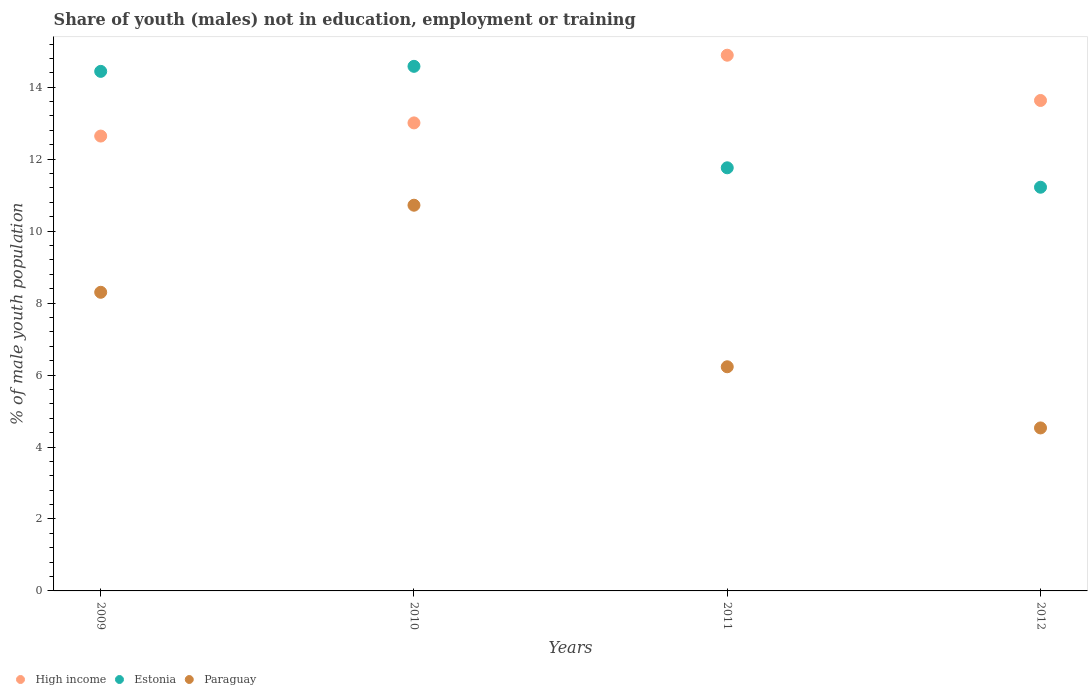How many different coloured dotlines are there?
Provide a succinct answer. 3. What is the percentage of unemployed males population in in High income in 2009?
Your answer should be compact. 12.64. Across all years, what is the maximum percentage of unemployed males population in in Estonia?
Make the answer very short. 14.58. Across all years, what is the minimum percentage of unemployed males population in in Estonia?
Offer a very short reply. 11.22. In which year was the percentage of unemployed males population in in Estonia maximum?
Provide a short and direct response. 2010. In which year was the percentage of unemployed males population in in Estonia minimum?
Provide a short and direct response. 2012. What is the total percentage of unemployed males population in in Paraguay in the graph?
Ensure brevity in your answer.  29.78. What is the difference between the percentage of unemployed males population in in Estonia in 2010 and that in 2011?
Ensure brevity in your answer.  2.82. What is the difference between the percentage of unemployed males population in in Paraguay in 2009 and the percentage of unemployed males population in in Estonia in 2012?
Provide a short and direct response. -2.92. What is the average percentage of unemployed males population in in Paraguay per year?
Provide a short and direct response. 7.45. In the year 2010, what is the difference between the percentage of unemployed males population in in High income and percentage of unemployed males population in in Estonia?
Your response must be concise. -1.57. In how many years, is the percentage of unemployed males population in in Estonia greater than 4 %?
Your response must be concise. 4. What is the ratio of the percentage of unemployed males population in in High income in 2009 to that in 2011?
Keep it short and to the point. 0.85. What is the difference between the highest and the second highest percentage of unemployed males population in in Paraguay?
Offer a very short reply. 2.42. What is the difference between the highest and the lowest percentage of unemployed males population in in High income?
Your answer should be very brief. 2.25. Is the percentage of unemployed males population in in Paraguay strictly greater than the percentage of unemployed males population in in Estonia over the years?
Provide a succinct answer. No. How many years are there in the graph?
Your answer should be very brief. 4. Are the values on the major ticks of Y-axis written in scientific E-notation?
Your answer should be compact. No. Where does the legend appear in the graph?
Keep it short and to the point. Bottom left. How many legend labels are there?
Provide a short and direct response. 3. How are the legend labels stacked?
Give a very brief answer. Horizontal. What is the title of the graph?
Your response must be concise. Share of youth (males) not in education, employment or training. What is the label or title of the X-axis?
Make the answer very short. Years. What is the label or title of the Y-axis?
Provide a short and direct response. % of male youth population. What is the % of male youth population in High income in 2009?
Keep it short and to the point. 12.64. What is the % of male youth population of Estonia in 2009?
Provide a short and direct response. 14.44. What is the % of male youth population in Paraguay in 2009?
Offer a very short reply. 8.3. What is the % of male youth population of High income in 2010?
Offer a very short reply. 13.01. What is the % of male youth population in Estonia in 2010?
Keep it short and to the point. 14.58. What is the % of male youth population of Paraguay in 2010?
Keep it short and to the point. 10.72. What is the % of male youth population of High income in 2011?
Make the answer very short. 14.89. What is the % of male youth population in Estonia in 2011?
Provide a short and direct response. 11.76. What is the % of male youth population in Paraguay in 2011?
Keep it short and to the point. 6.23. What is the % of male youth population of High income in 2012?
Ensure brevity in your answer.  13.63. What is the % of male youth population of Estonia in 2012?
Make the answer very short. 11.22. What is the % of male youth population of Paraguay in 2012?
Your response must be concise. 4.53. Across all years, what is the maximum % of male youth population of High income?
Your response must be concise. 14.89. Across all years, what is the maximum % of male youth population in Estonia?
Give a very brief answer. 14.58. Across all years, what is the maximum % of male youth population of Paraguay?
Provide a succinct answer. 10.72. Across all years, what is the minimum % of male youth population in High income?
Your answer should be compact. 12.64. Across all years, what is the minimum % of male youth population in Estonia?
Give a very brief answer. 11.22. Across all years, what is the minimum % of male youth population in Paraguay?
Your answer should be compact. 4.53. What is the total % of male youth population of High income in the graph?
Provide a succinct answer. 54.17. What is the total % of male youth population of Paraguay in the graph?
Offer a very short reply. 29.78. What is the difference between the % of male youth population in High income in 2009 and that in 2010?
Give a very brief answer. -0.37. What is the difference between the % of male youth population in Estonia in 2009 and that in 2010?
Give a very brief answer. -0.14. What is the difference between the % of male youth population in Paraguay in 2009 and that in 2010?
Provide a succinct answer. -2.42. What is the difference between the % of male youth population in High income in 2009 and that in 2011?
Give a very brief answer. -2.25. What is the difference between the % of male youth population of Estonia in 2009 and that in 2011?
Your answer should be very brief. 2.68. What is the difference between the % of male youth population of Paraguay in 2009 and that in 2011?
Provide a succinct answer. 2.07. What is the difference between the % of male youth population in High income in 2009 and that in 2012?
Give a very brief answer. -0.99. What is the difference between the % of male youth population in Estonia in 2009 and that in 2012?
Provide a short and direct response. 3.22. What is the difference between the % of male youth population in Paraguay in 2009 and that in 2012?
Provide a short and direct response. 3.77. What is the difference between the % of male youth population in High income in 2010 and that in 2011?
Provide a short and direct response. -1.88. What is the difference between the % of male youth population of Estonia in 2010 and that in 2011?
Make the answer very short. 2.82. What is the difference between the % of male youth population of Paraguay in 2010 and that in 2011?
Give a very brief answer. 4.49. What is the difference between the % of male youth population in High income in 2010 and that in 2012?
Ensure brevity in your answer.  -0.62. What is the difference between the % of male youth population of Estonia in 2010 and that in 2012?
Your response must be concise. 3.36. What is the difference between the % of male youth population of Paraguay in 2010 and that in 2012?
Offer a very short reply. 6.19. What is the difference between the % of male youth population of High income in 2011 and that in 2012?
Offer a terse response. 1.26. What is the difference between the % of male youth population in Estonia in 2011 and that in 2012?
Provide a short and direct response. 0.54. What is the difference between the % of male youth population in High income in 2009 and the % of male youth population in Estonia in 2010?
Your answer should be compact. -1.94. What is the difference between the % of male youth population in High income in 2009 and the % of male youth population in Paraguay in 2010?
Give a very brief answer. 1.92. What is the difference between the % of male youth population in Estonia in 2009 and the % of male youth population in Paraguay in 2010?
Ensure brevity in your answer.  3.72. What is the difference between the % of male youth population in High income in 2009 and the % of male youth population in Estonia in 2011?
Provide a succinct answer. 0.88. What is the difference between the % of male youth population of High income in 2009 and the % of male youth population of Paraguay in 2011?
Ensure brevity in your answer.  6.41. What is the difference between the % of male youth population in Estonia in 2009 and the % of male youth population in Paraguay in 2011?
Give a very brief answer. 8.21. What is the difference between the % of male youth population of High income in 2009 and the % of male youth population of Estonia in 2012?
Ensure brevity in your answer.  1.42. What is the difference between the % of male youth population in High income in 2009 and the % of male youth population in Paraguay in 2012?
Provide a short and direct response. 8.11. What is the difference between the % of male youth population of Estonia in 2009 and the % of male youth population of Paraguay in 2012?
Your response must be concise. 9.91. What is the difference between the % of male youth population in High income in 2010 and the % of male youth population in Estonia in 2011?
Offer a terse response. 1.25. What is the difference between the % of male youth population of High income in 2010 and the % of male youth population of Paraguay in 2011?
Make the answer very short. 6.78. What is the difference between the % of male youth population in Estonia in 2010 and the % of male youth population in Paraguay in 2011?
Offer a very short reply. 8.35. What is the difference between the % of male youth population of High income in 2010 and the % of male youth population of Estonia in 2012?
Your answer should be compact. 1.79. What is the difference between the % of male youth population in High income in 2010 and the % of male youth population in Paraguay in 2012?
Provide a succinct answer. 8.48. What is the difference between the % of male youth population of Estonia in 2010 and the % of male youth population of Paraguay in 2012?
Provide a succinct answer. 10.05. What is the difference between the % of male youth population in High income in 2011 and the % of male youth population in Estonia in 2012?
Keep it short and to the point. 3.67. What is the difference between the % of male youth population of High income in 2011 and the % of male youth population of Paraguay in 2012?
Your answer should be very brief. 10.36. What is the difference between the % of male youth population of Estonia in 2011 and the % of male youth population of Paraguay in 2012?
Provide a short and direct response. 7.23. What is the average % of male youth population of High income per year?
Make the answer very short. 13.54. What is the average % of male youth population in Paraguay per year?
Ensure brevity in your answer.  7.45. In the year 2009, what is the difference between the % of male youth population in High income and % of male youth population in Estonia?
Provide a succinct answer. -1.8. In the year 2009, what is the difference between the % of male youth population of High income and % of male youth population of Paraguay?
Offer a very short reply. 4.34. In the year 2009, what is the difference between the % of male youth population in Estonia and % of male youth population in Paraguay?
Provide a succinct answer. 6.14. In the year 2010, what is the difference between the % of male youth population in High income and % of male youth population in Estonia?
Your response must be concise. -1.57. In the year 2010, what is the difference between the % of male youth population in High income and % of male youth population in Paraguay?
Ensure brevity in your answer.  2.29. In the year 2010, what is the difference between the % of male youth population of Estonia and % of male youth population of Paraguay?
Keep it short and to the point. 3.86. In the year 2011, what is the difference between the % of male youth population in High income and % of male youth population in Estonia?
Provide a short and direct response. 3.13. In the year 2011, what is the difference between the % of male youth population of High income and % of male youth population of Paraguay?
Provide a short and direct response. 8.66. In the year 2011, what is the difference between the % of male youth population in Estonia and % of male youth population in Paraguay?
Give a very brief answer. 5.53. In the year 2012, what is the difference between the % of male youth population of High income and % of male youth population of Estonia?
Ensure brevity in your answer.  2.41. In the year 2012, what is the difference between the % of male youth population of High income and % of male youth population of Paraguay?
Your answer should be very brief. 9.1. In the year 2012, what is the difference between the % of male youth population in Estonia and % of male youth population in Paraguay?
Ensure brevity in your answer.  6.69. What is the ratio of the % of male youth population in High income in 2009 to that in 2010?
Your answer should be very brief. 0.97. What is the ratio of the % of male youth population of Paraguay in 2009 to that in 2010?
Provide a short and direct response. 0.77. What is the ratio of the % of male youth population of High income in 2009 to that in 2011?
Ensure brevity in your answer.  0.85. What is the ratio of the % of male youth population in Estonia in 2009 to that in 2011?
Your answer should be compact. 1.23. What is the ratio of the % of male youth population in Paraguay in 2009 to that in 2011?
Ensure brevity in your answer.  1.33. What is the ratio of the % of male youth population of High income in 2009 to that in 2012?
Provide a succinct answer. 0.93. What is the ratio of the % of male youth population in Estonia in 2009 to that in 2012?
Offer a very short reply. 1.29. What is the ratio of the % of male youth population in Paraguay in 2009 to that in 2012?
Ensure brevity in your answer.  1.83. What is the ratio of the % of male youth population of High income in 2010 to that in 2011?
Provide a succinct answer. 0.87. What is the ratio of the % of male youth population of Estonia in 2010 to that in 2011?
Provide a short and direct response. 1.24. What is the ratio of the % of male youth population in Paraguay in 2010 to that in 2011?
Ensure brevity in your answer.  1.72. What is the ratio of the % of male youth population of High income in 2010 to that in 2012?
Ensure brevity in your answer.  0.95. What is the ratio of the % of male youth population in Estonia in 2010 to that in 2012?
Make the answer very short. 1.3. What is the ratio of the % of male youth population in Paraguay in 2010 to that in 2012?
Your answer should be very brief. 2.37. What is the ratio of the % of male youth population in High income in 2011 to that in 2012?
Make the answer very short. 1.09. What is the ratio of the % of male youth population of Estonia in 2011 to that in 2012?
Keep it short and to the point. 1.05. What is the ratio of the % of male youth population in Paraguay in 2011 to that in 2012?
Your response must be concise. 1.38. What is the difference between the highest and the second highest % of male youth population of High income?
Provide a short and direct response. 1.26. What is the difference between the highest and the second highest % of male youth population in Estonia?
Provide a short and direct response. 0.14. What is the difference between the highest and the second highest % of male youth population of Paraguay?
Give a very brief answer. 2.42. What is the difference between the highest and the lowest % of male youth population in High income?
Make the answer very short. 2.25. What is the difference between the highest and the lowest % of male youth population of Estonia?
Your answer should be compact. 3.36. What is the difference between the highest and the lowest % of male youth population of Paraguay?
Provide a succinct answer. 6.19. 